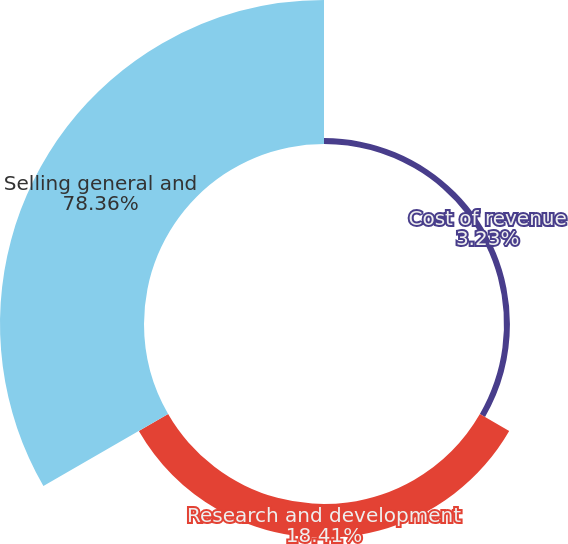<chart> <loc_0><loc_0><loc_500><loc_500><pie_chart><fcel>Cost of revenue<fcel>Research and development<fcel>Selling general and<nl><fcel>3.23%<fcel>18.41%<fcel>78.36%<nl></chart> 